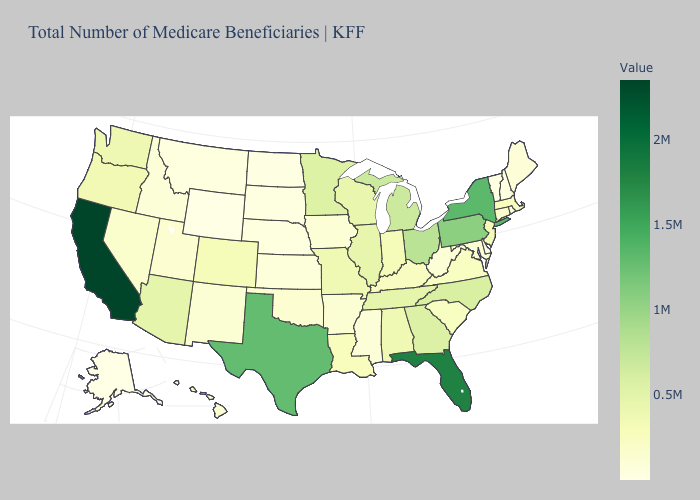Does Oregon have a lower value than Alaska?
Write a very short answer. No. Is the legend a continuous bar?
Keep it brief. Yes. Does Alabama have a lower value than Wyoming?
Answer briefly. No. 